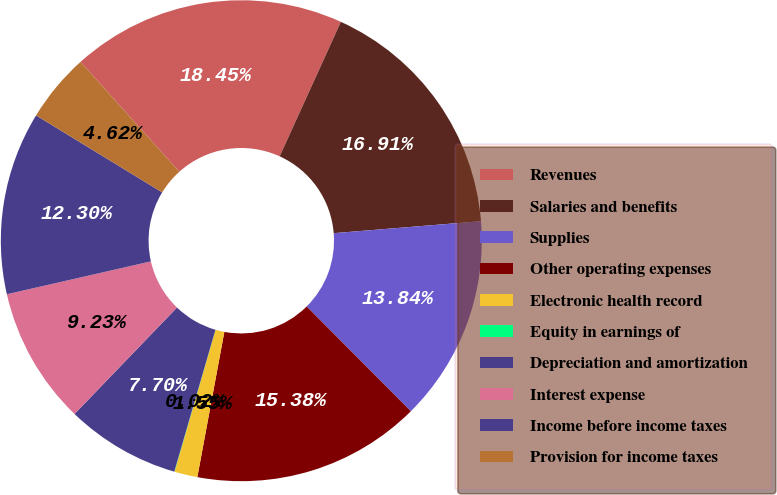Convert chart to OTSL. <chart><loc_0><loc_0><loc_500><loc_500><pie_chart><fcel>Revenues<fcel>Salaries and benefits<fcel>Supplies<fcel>Other operating expenses<fcel>Electronic health record<fcel>Equity in earnings of<fcel>Depreciation and amortization<fcel>Interest expense<fcel>Income before income taxes<fcel>Provision for income taxes<nl><fcel>18.45%<fcel>16.91%<fcel>13.84%<fcel>15.38%<fcel>1.55%<fcel>0.02%<fcel>7.7%<fcel>9.23%<fcel>12.3%<fcel>4.62%<nl></chart> 